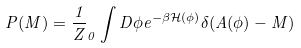Convert formula to latex. <formula><loc_0><loc_0><loc_500><loc_500>P ( M ) = \frac { 1 } { Z } _ { 0 } \int D \phi e ^ { - \beta \mathcal { H } ( \phi ) } \delta ( A ( \phi ) - M )</formula> 